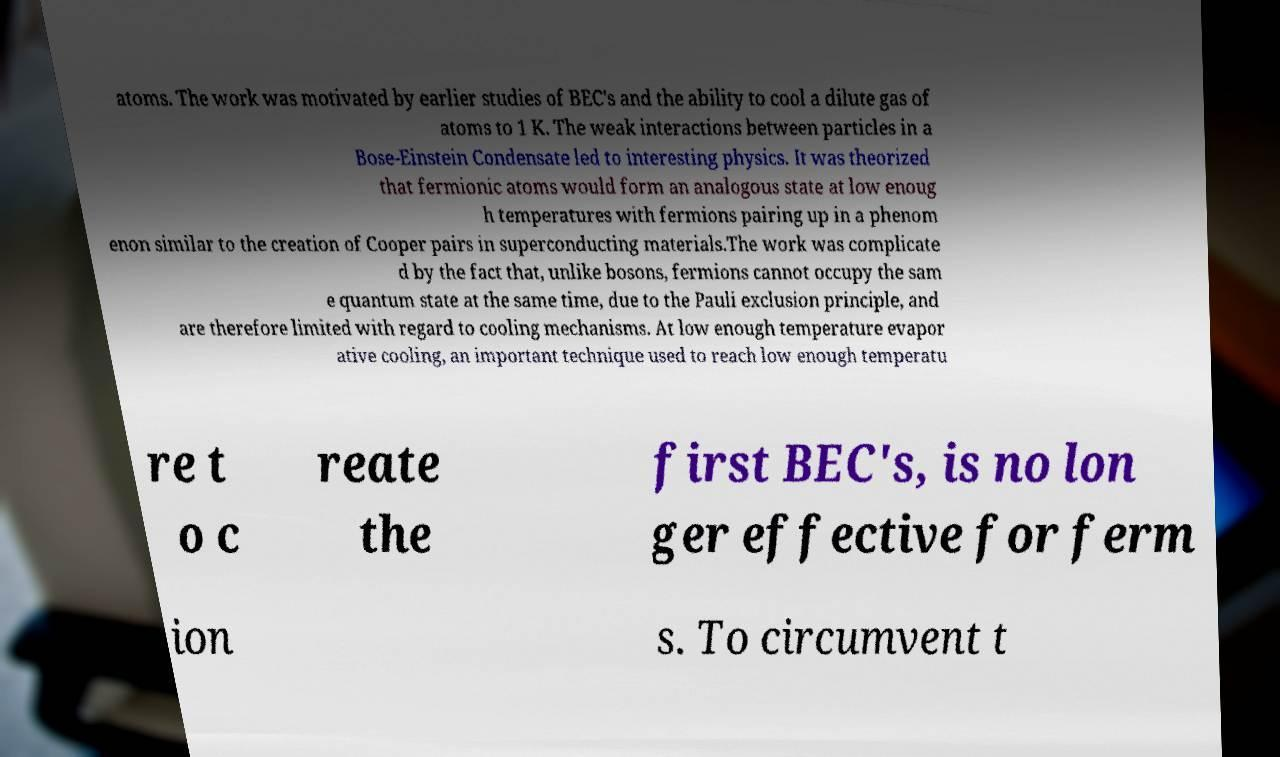Could you extract and type out the text from this image? atoms. The work was motivated by earlier studies of BEC's and the ability to cool a dilute gas of atoms to 1 K. The weak interactions between particles in a Bose-Einstein Condensate led to interesting physics. It was theorized that fermionic atoms would form an analogous state at low enoug h temperatures with fermions pairing up in a phenom enon similar to the creation of Cooper pairs in superconducting materials.The work was complicate d by the fact that, unlike bosons, fermions cannot occupy the sam e quantum state at the same time, due to the Pauli exclusion principle, and are therefore limited with regard to cooling mechanisms. At low enough temperature evapor ative cooling, an important technique used to reach low enough temperatu re t o c reate the first BEC's, is no lon ger effective for ferm ion s. To circumvent t 